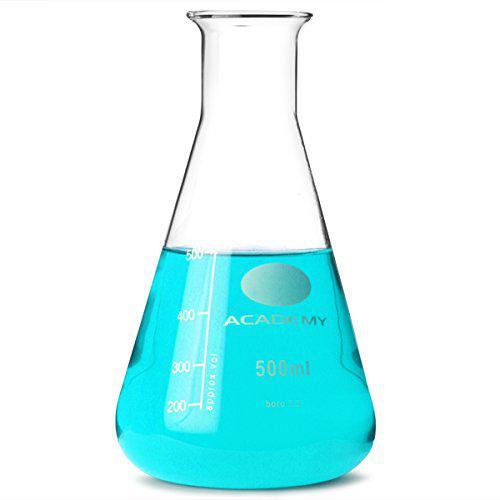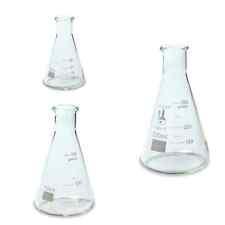The first image is the image on the left, the second image is the image on the right. For the images displayed, is the sentence "The image to the left contains a flask with a blue tinted liquid inside." factually correct? Answer yes or no. Yes. The first image is the image on the left, the second image is the image on the right. Considering the images on both sides, is "There is no less than one clear beaker filled with a blue liquid" valid? Answer yes or no. Yes. 